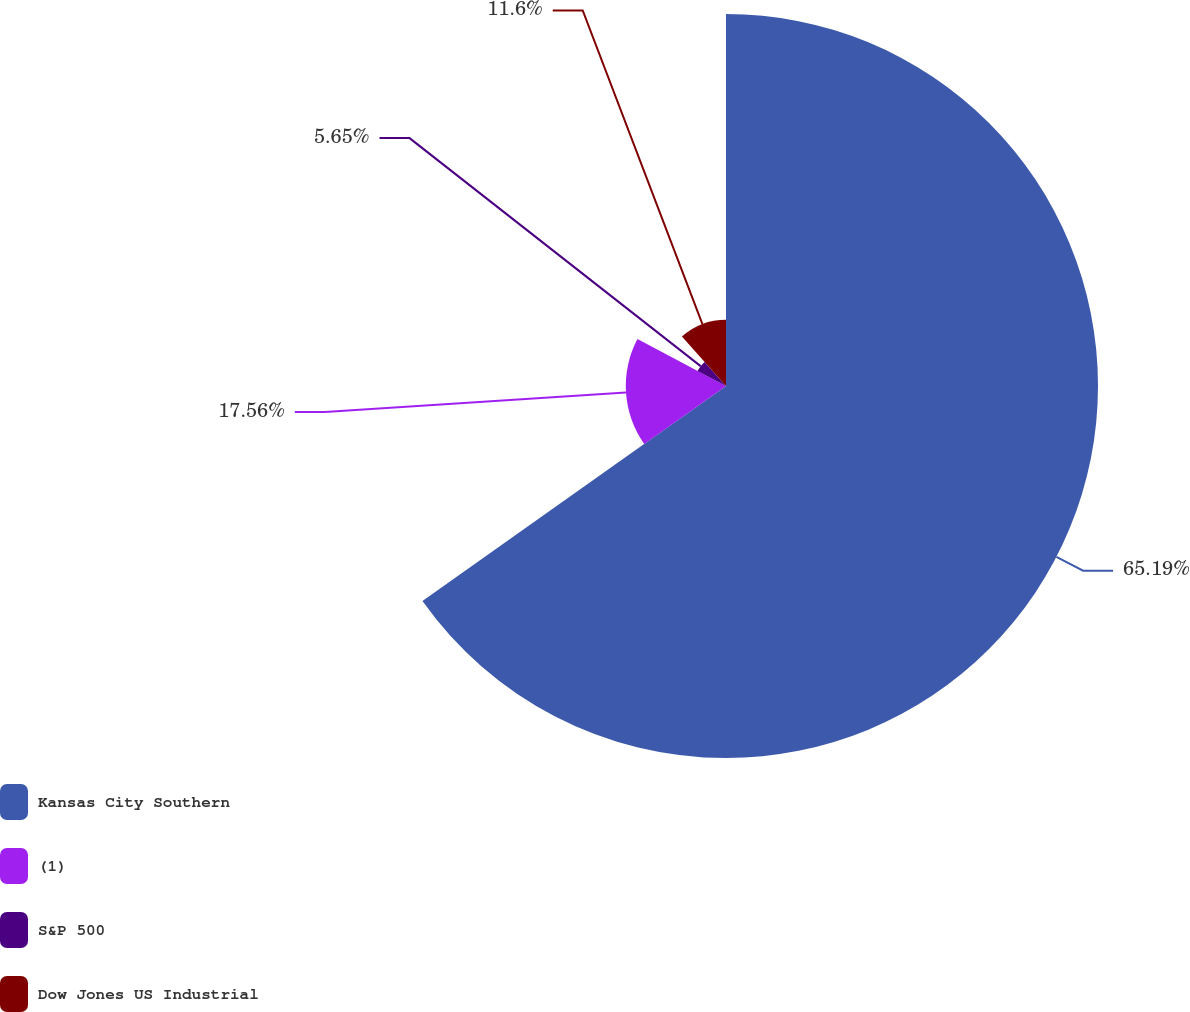Convert chart. <chart><loc_0><loc_0><loc_500><loc_500><pie_chart><fcel>Kansas City Southern<fcel>(1)<fcel>S&P 500<fcel>Dow Jones US Industrial<nl><fcel>65.19%<fcel>17.56%<fcel>5.65%<fcel>11.6%<nl></chart> 